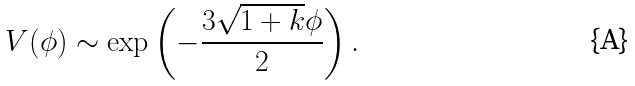<formula> <loc_0><loc_0><loc_500><loc_500>V ( \phi ) \sim \exp \left ( - \frac { 3 \sqrt { 1 + k } \phi } { 2 } \right ) .</formula> 